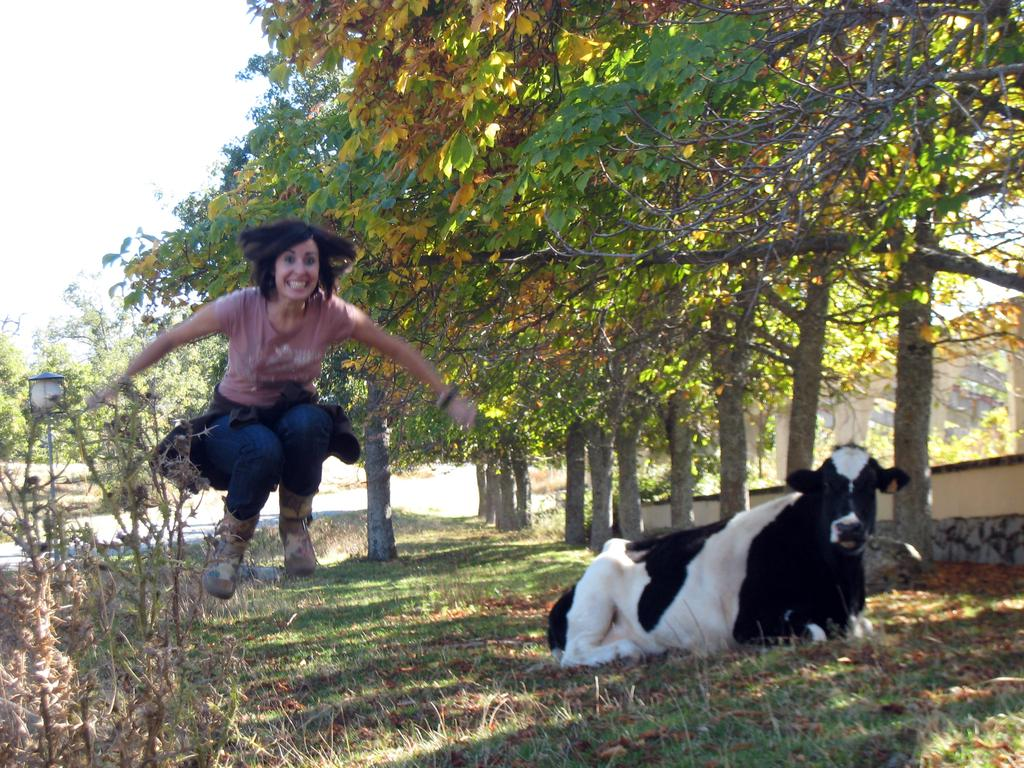What animal can be seen in the image? There is a cow on the grass in the image. Where is the cow located? The cow is on the grass in the image. What type of vegetation is present in the image? There are plants and trees in the image. What is the source of light in the image? There is a light source in the image. What is the woman in the image doing? The woman is in motion in the image. What is visible in the background of the image? The sky is visible in the background of the image. How many fairies are flying around the cow in the image? There are no fairies present in the image. Can you tell me the breed of the cats visible in the image? There are no cats present in the image. 